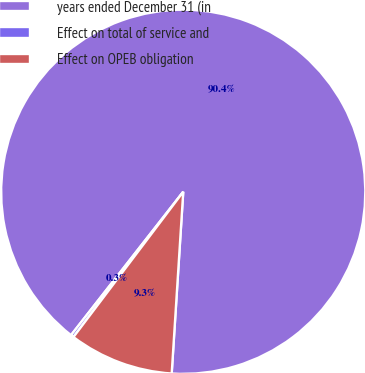Convert chart to OTSL. <chart><loc_0><loc_0><loc_500><loc_500><pie_chart><fcel>years ended December 31 (in<fcel>Effect on total of service and<fcel>Effect on OPEB obligation<nl><fcel>90.44%<fcel>0.27%<fcel>9.29%<nl></chart> 